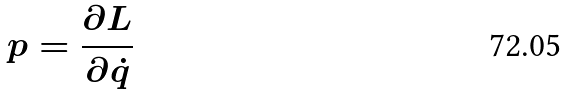Convert formula to latex. <formula><loc_0><loc_0><loc_500><loc_500>p = \frac { \partial L } { \partial \dot { q } }</formula> 